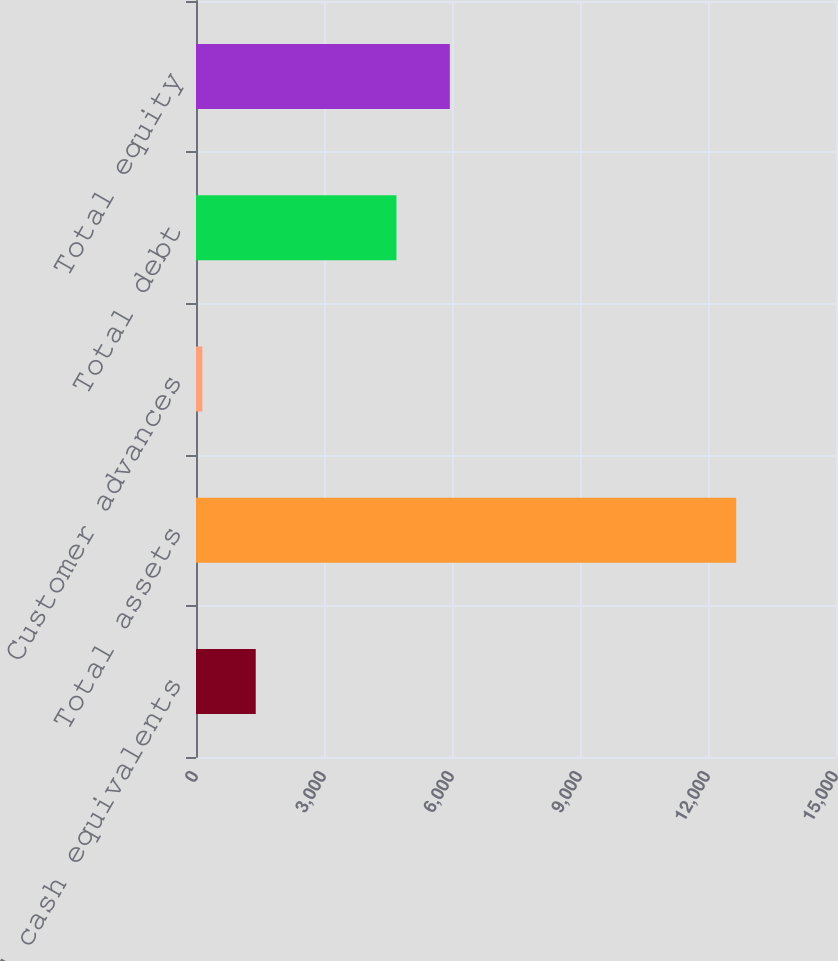Convert chart. <chart><loc_0><loc_0><loc_500><loc_500><bar_chart><fcel>Cash and cash equivalents<fcel>Total assets<fcel>Customer advances<fcel>Total debt<fcel>Total equity<nl><fcel>1400.2<fcel>12661<fcel>149<fcel>4698<fcel>5949.2<nl></chart> 